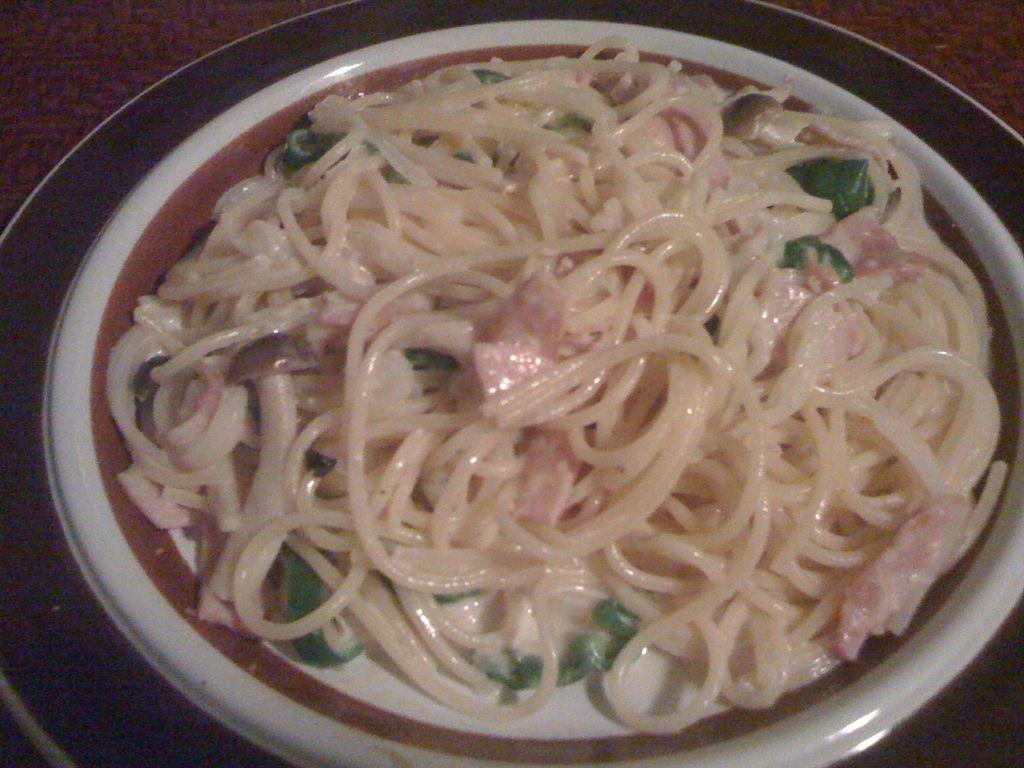In one or two sentences, can you explain what this image depicts? In this image, I can see a plate. This plate contains noodles, mushrooms and some other ingredients. 